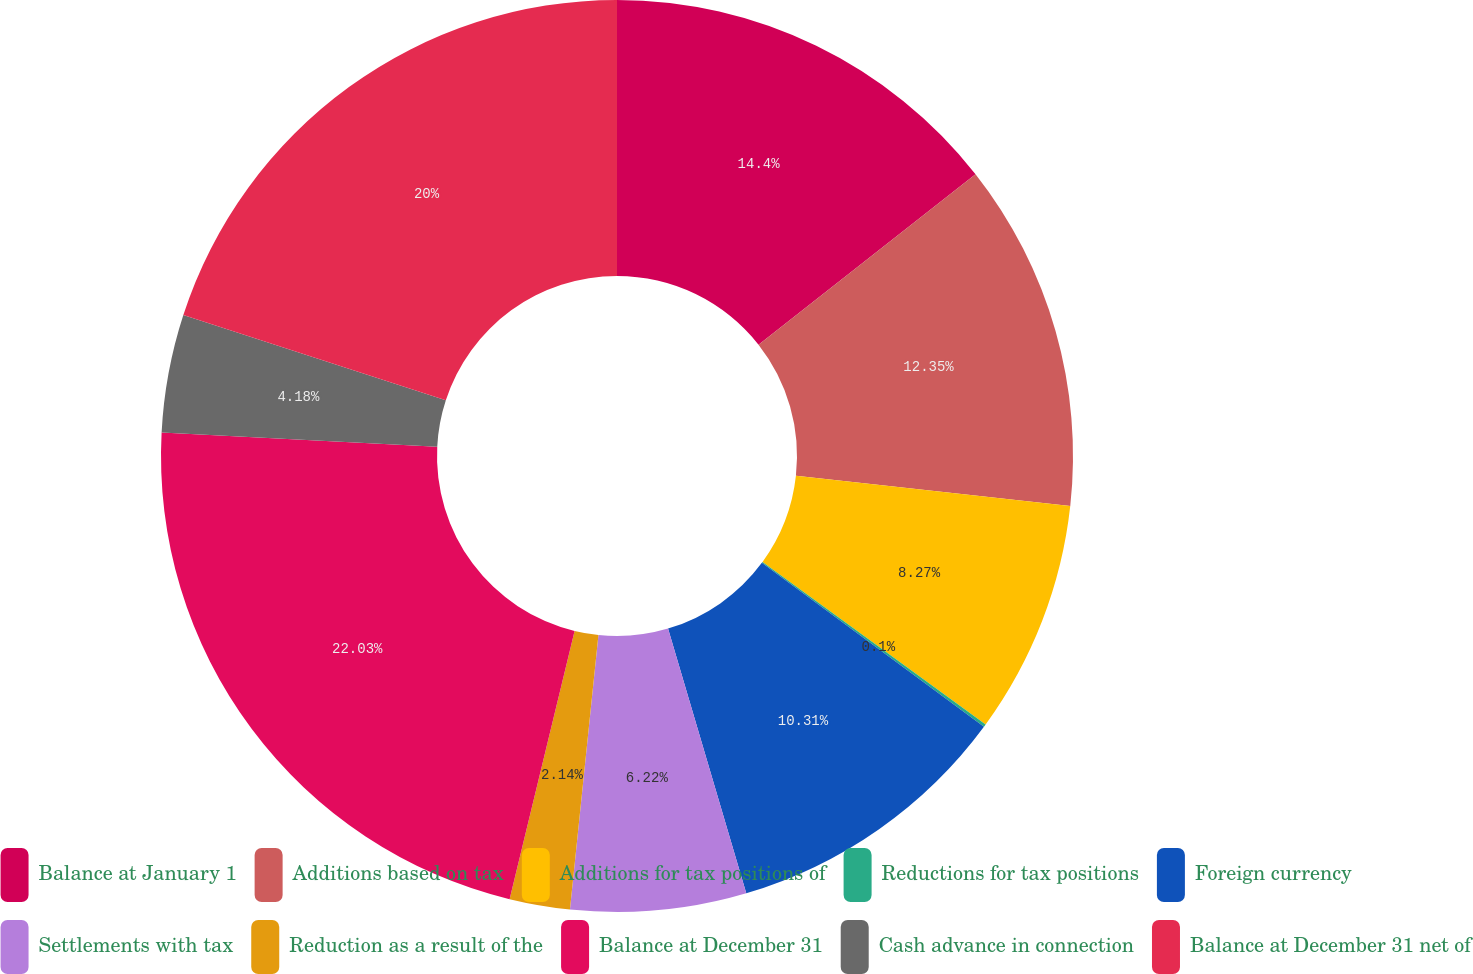<chart> <loc_0><loc_0><loc_500><loc_500><pie_chart><fcel>Balance at January 1<fcel>Additions based on tax<fcel>Additions for tax positions of<fcel>Reductions for tax positions<fcel>Foreign currency<fcel>Settlements with tax<fcel>Reduction as a result of the<fcel>Balance at December 31<fcel>Cash advance in connection<fcel>Balance at December 31 net of<nl><fcel>14.4%<fcel>12.35%<fcel>8.27%<fcel>0.1%<fcel>10.31%<fcel>6.22%<fcel>2.14%<fcel>22.04%<fcel>4.18%<fcel>20.0%<nl></chart> 